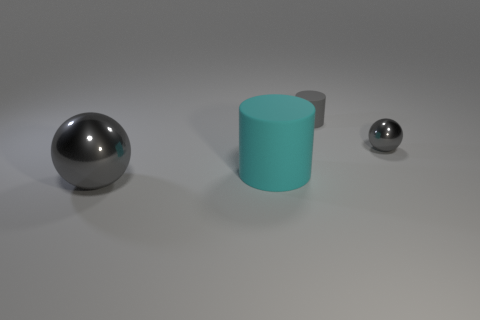Add 3 gray cubes. How many objects exist? 7 Add 2 balls. How many balls exist? 4 Subtract 0 green spheres. How many objects are left? 4 Subtract all gray objects. Subtract all small gray spheres. How many objects are left? 0 Add 2 large metallic balls. How many large metallic balls are left? 3 